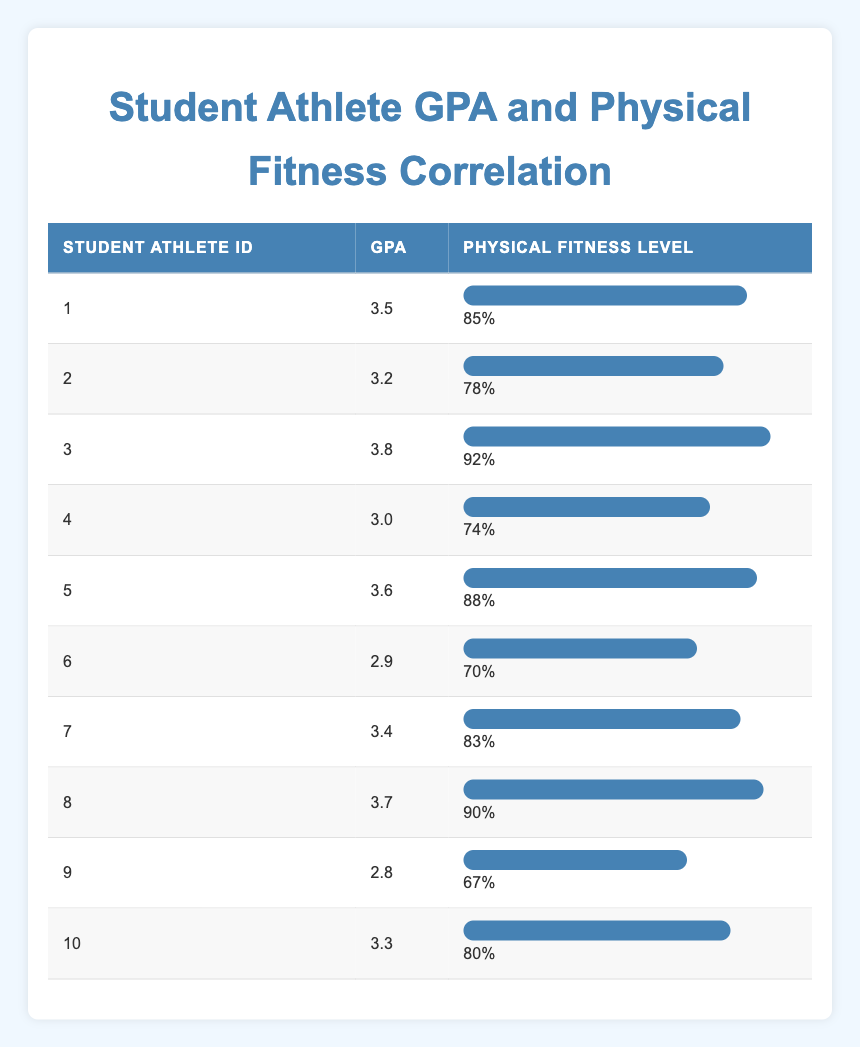What is the GPA of the student athlete with ID 3? The GPA for student athlete ID 3 is directly listed in the table under the GPA column. It shows 3.8.
Answer: 3.8 What is the physical fitness level of the student athlete with ID 7? Referring to the table, the physical fitness level for student athlete ID 7 is 83%.
Answer: 83% Which student athlete has the highest GPA? By examining the GPA column, student athlete ID 3 has the highest GPA of 3.8 compared to the other students.
Answer: 3.8 Is there a student athlete with a GPA lower than 3.0? Looking through the table, student athlete ID 6 has a GPA of 2.9, confirming there is a student athlete with a GPA lower than 3.0.
Answer: Yes What is the average GPA of all the student athletes? To calculate the average GPA, sum all the GPAs: (3.5 + 3.2 + 3.8 + 3.0 + 3.6 + 2.9 + 3.4 + 3.7 + 2.8 + 3.3) = 33.2. Since there are 10 data points, the average is 33.2 / 10 = 3.32.
Answer: 3.32 What is the difference between the highest and lowest physical fitness levels? The highest physical fitness level is 92% (ID 3) and the lowest is 67% (ID 9). The difference is 92 - 67 = 25%.
Answer: 25% How many student athletes have a GPA above 3.5? By counting from the table, the student athletes with GPAs above 3.5 are ID 1 (3.5), ID 3 (3.8), ID 5 (3.6), and ID 8 (3.7), making a total of 4 student athletes.
Answer: 4 Which ID corresponds to the student with a GPA of 2.8? The table shows that the student athlete with a GPA of 2.8 is ID 9.
Answer: 9 Is the GPA of the student athlete with ID 10 higher than the average GPA? Comparing ID 10's GPA, which is 3.3, to the average GPA of 3.32, we see that it's slightly below the average.
Answer: No 